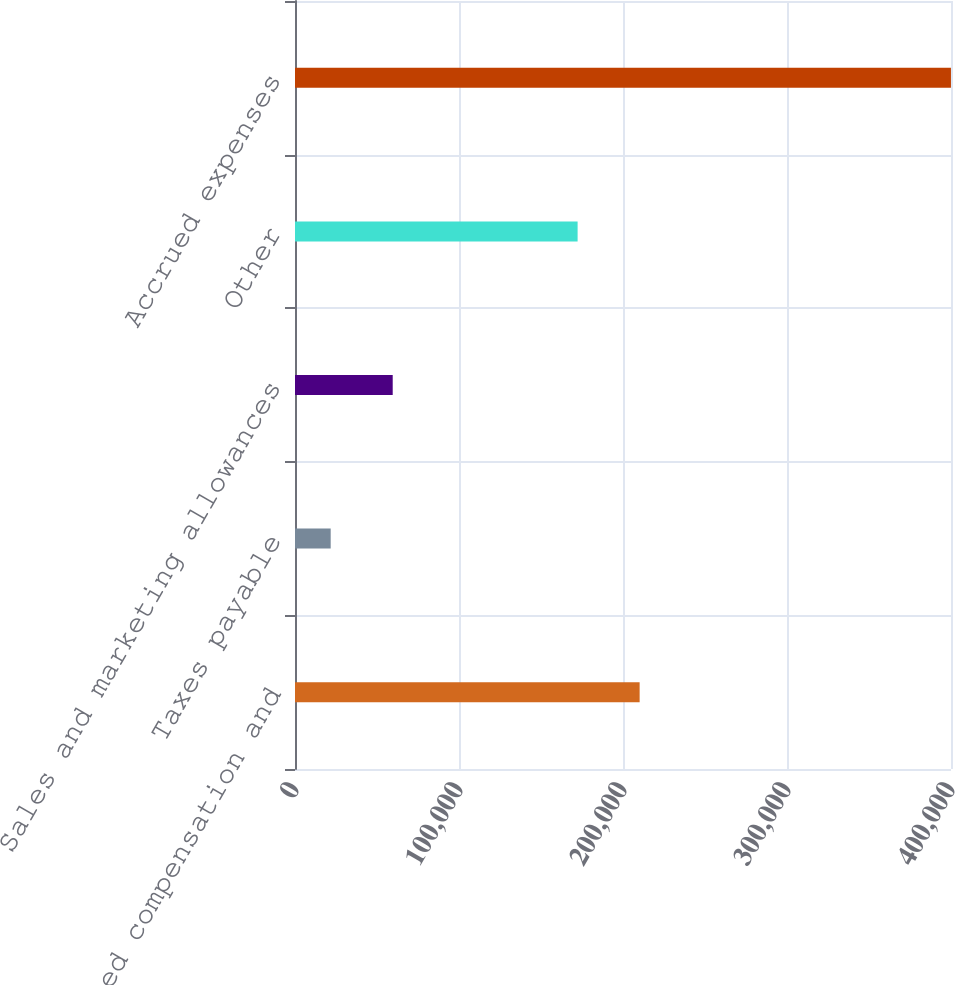Convert chart to OTSL. <chart><loc_0><loc_0><loc_500><loc_500><bar_chart><fcel>Accrued compensation and<fcel>Taxes payable<fcel>Sales and marketing allowances<fcel>Other<fcel>Accrued expenses<nl><fcel>210143<fcel>21760<fcel>59580.9<fcel>172322<fcel>399969<nl></chart> 